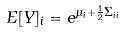<formula> <loc_0><loc_0><loc_500><loc_500>E [ Y ] _ { i } = e ^ { \mu _ { i } + \frac { 1 } { 2 } \Sigma _ { i i } }</formula> 